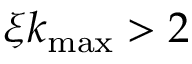<formula> <loc_0><loc_0><loc_500><loc_500>\xi k _ { \max } > 2</formula> 